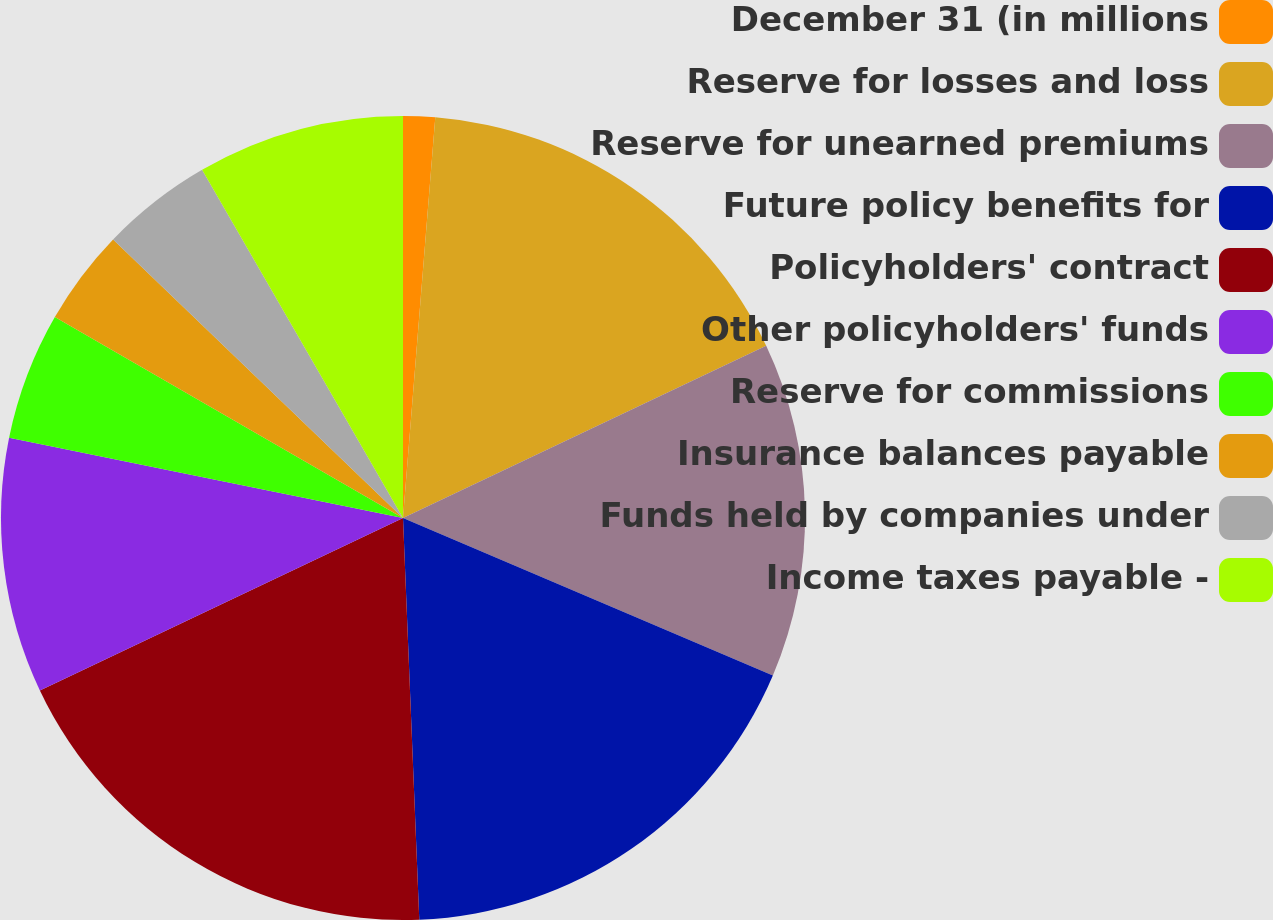Convert chart. <chart><loc_0><loc_0><loc_500><loc_500><pie_chart><fcel>December 31 (in millions<fcel>Reserve for losses and loss<fcel>Reserve for unearned premiums<fcel>Future policy benefits for<fcel>Policyholders' contract<fcel>Other policyholders' funds<fcel>Reserve for commissions<fcel>Insurance balances payable<fcel>Funds held by companies under<fcel>Income taxes payable -<nl><fcel>1.28%<fcel>16.67%<fcel>13.46%<fcel>17.95%<fcel>18.59%<fcel>10.26%<fcel>5.13%<fcel>3.85%<fcel>4.49%<fcel>8.33%<nl></chart> 